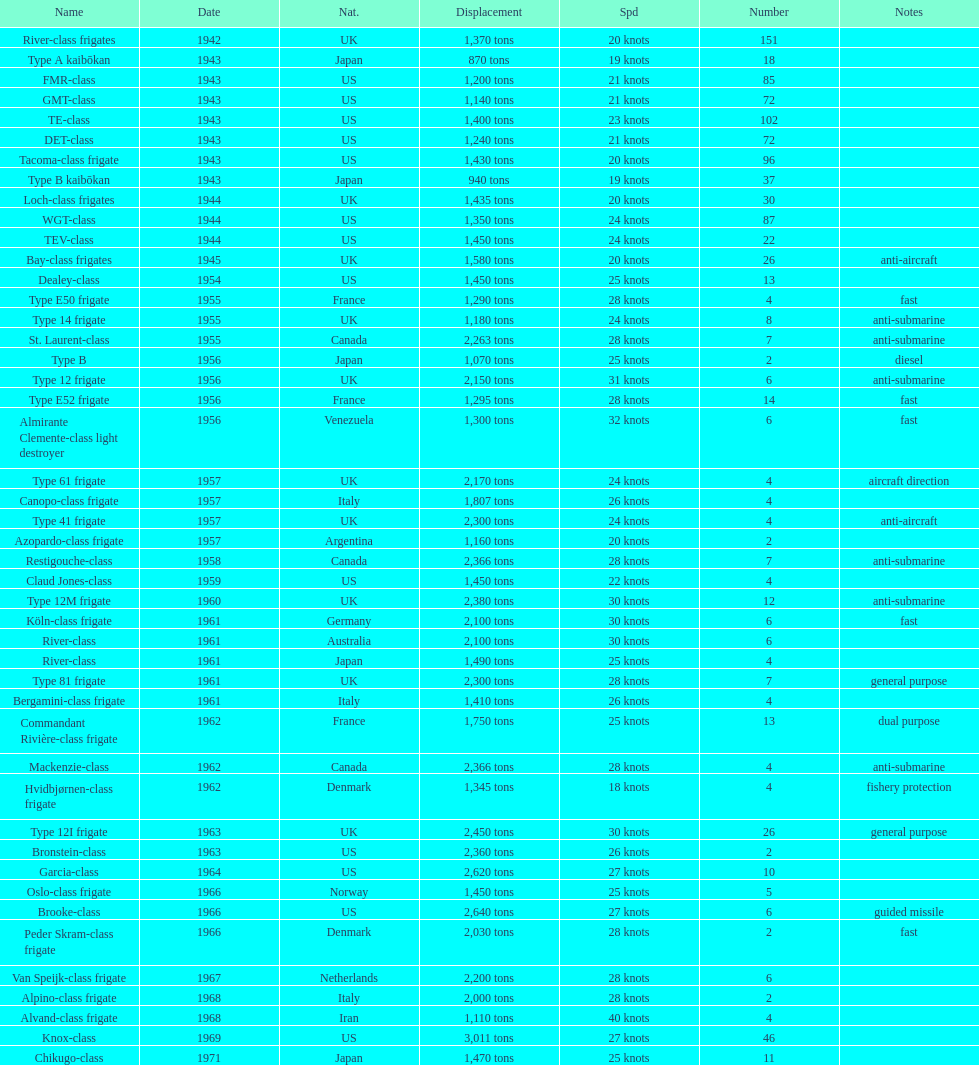Which name is associated with the greatest displacement? Knox-class. 